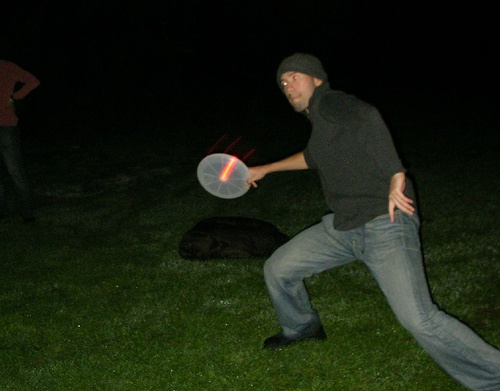Describe the objects in this image and their specific colors. I can see people in black and gray tones, dog in black tones, people in black tones, and frisbee in black and gray tones in this image. 